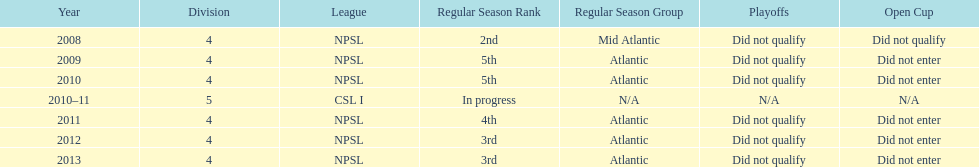How did they place the year after they were 4th in the regular season? 3rd. 